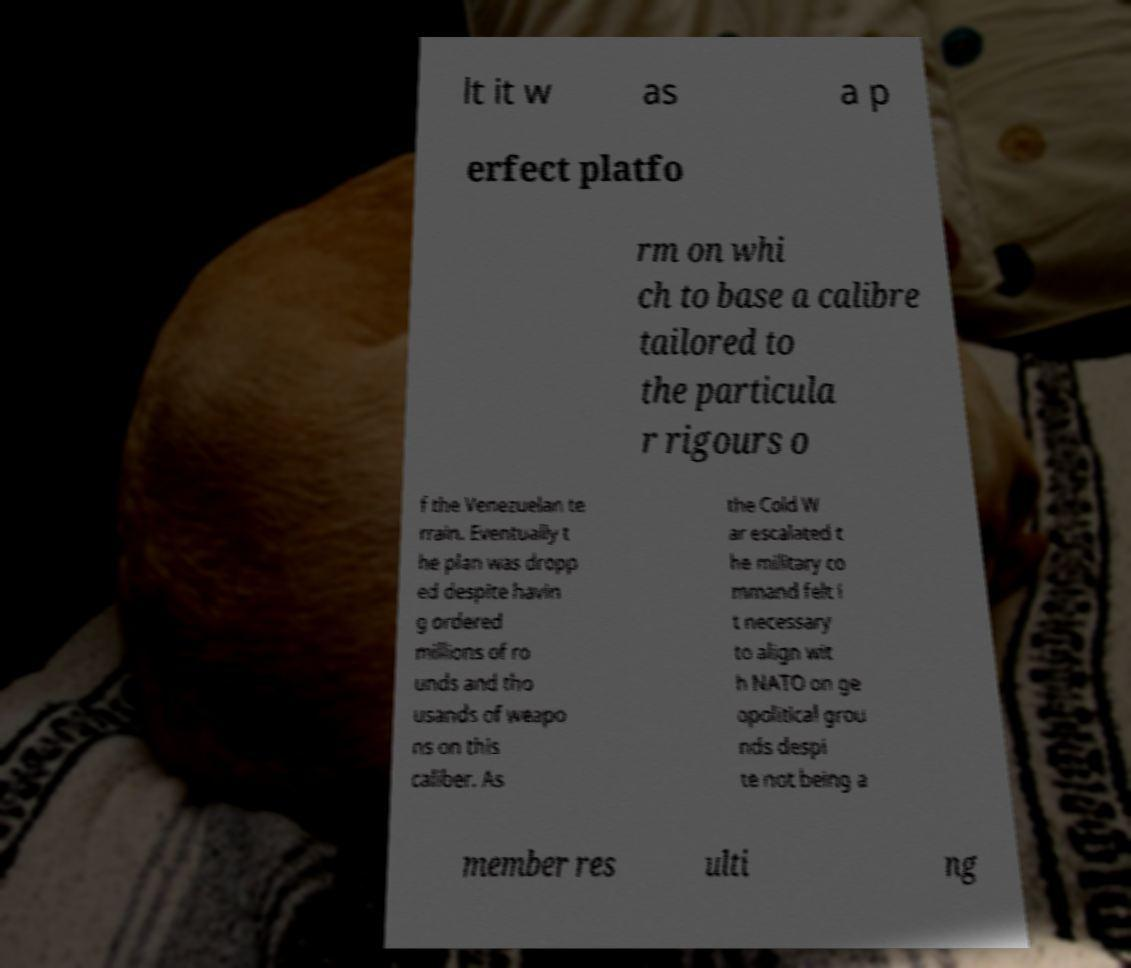There's text embedded in this image that I need extracted. Can you transcribe it verbatim? lt it w as a p erfect platfo rm on whi ch to base a calibre tailored to the particula r rigours o f the Venezuelan te rrain. Eventually t he plan was dropp ed despite havin g ordered millions of ro unds and tho usands of weapo ns on this caliber. As the Cold W ar escalated t he military co mmand felt i t necessary to align wit h NATO on ge opolitical grou nds despi te not being a member res ulti ng 